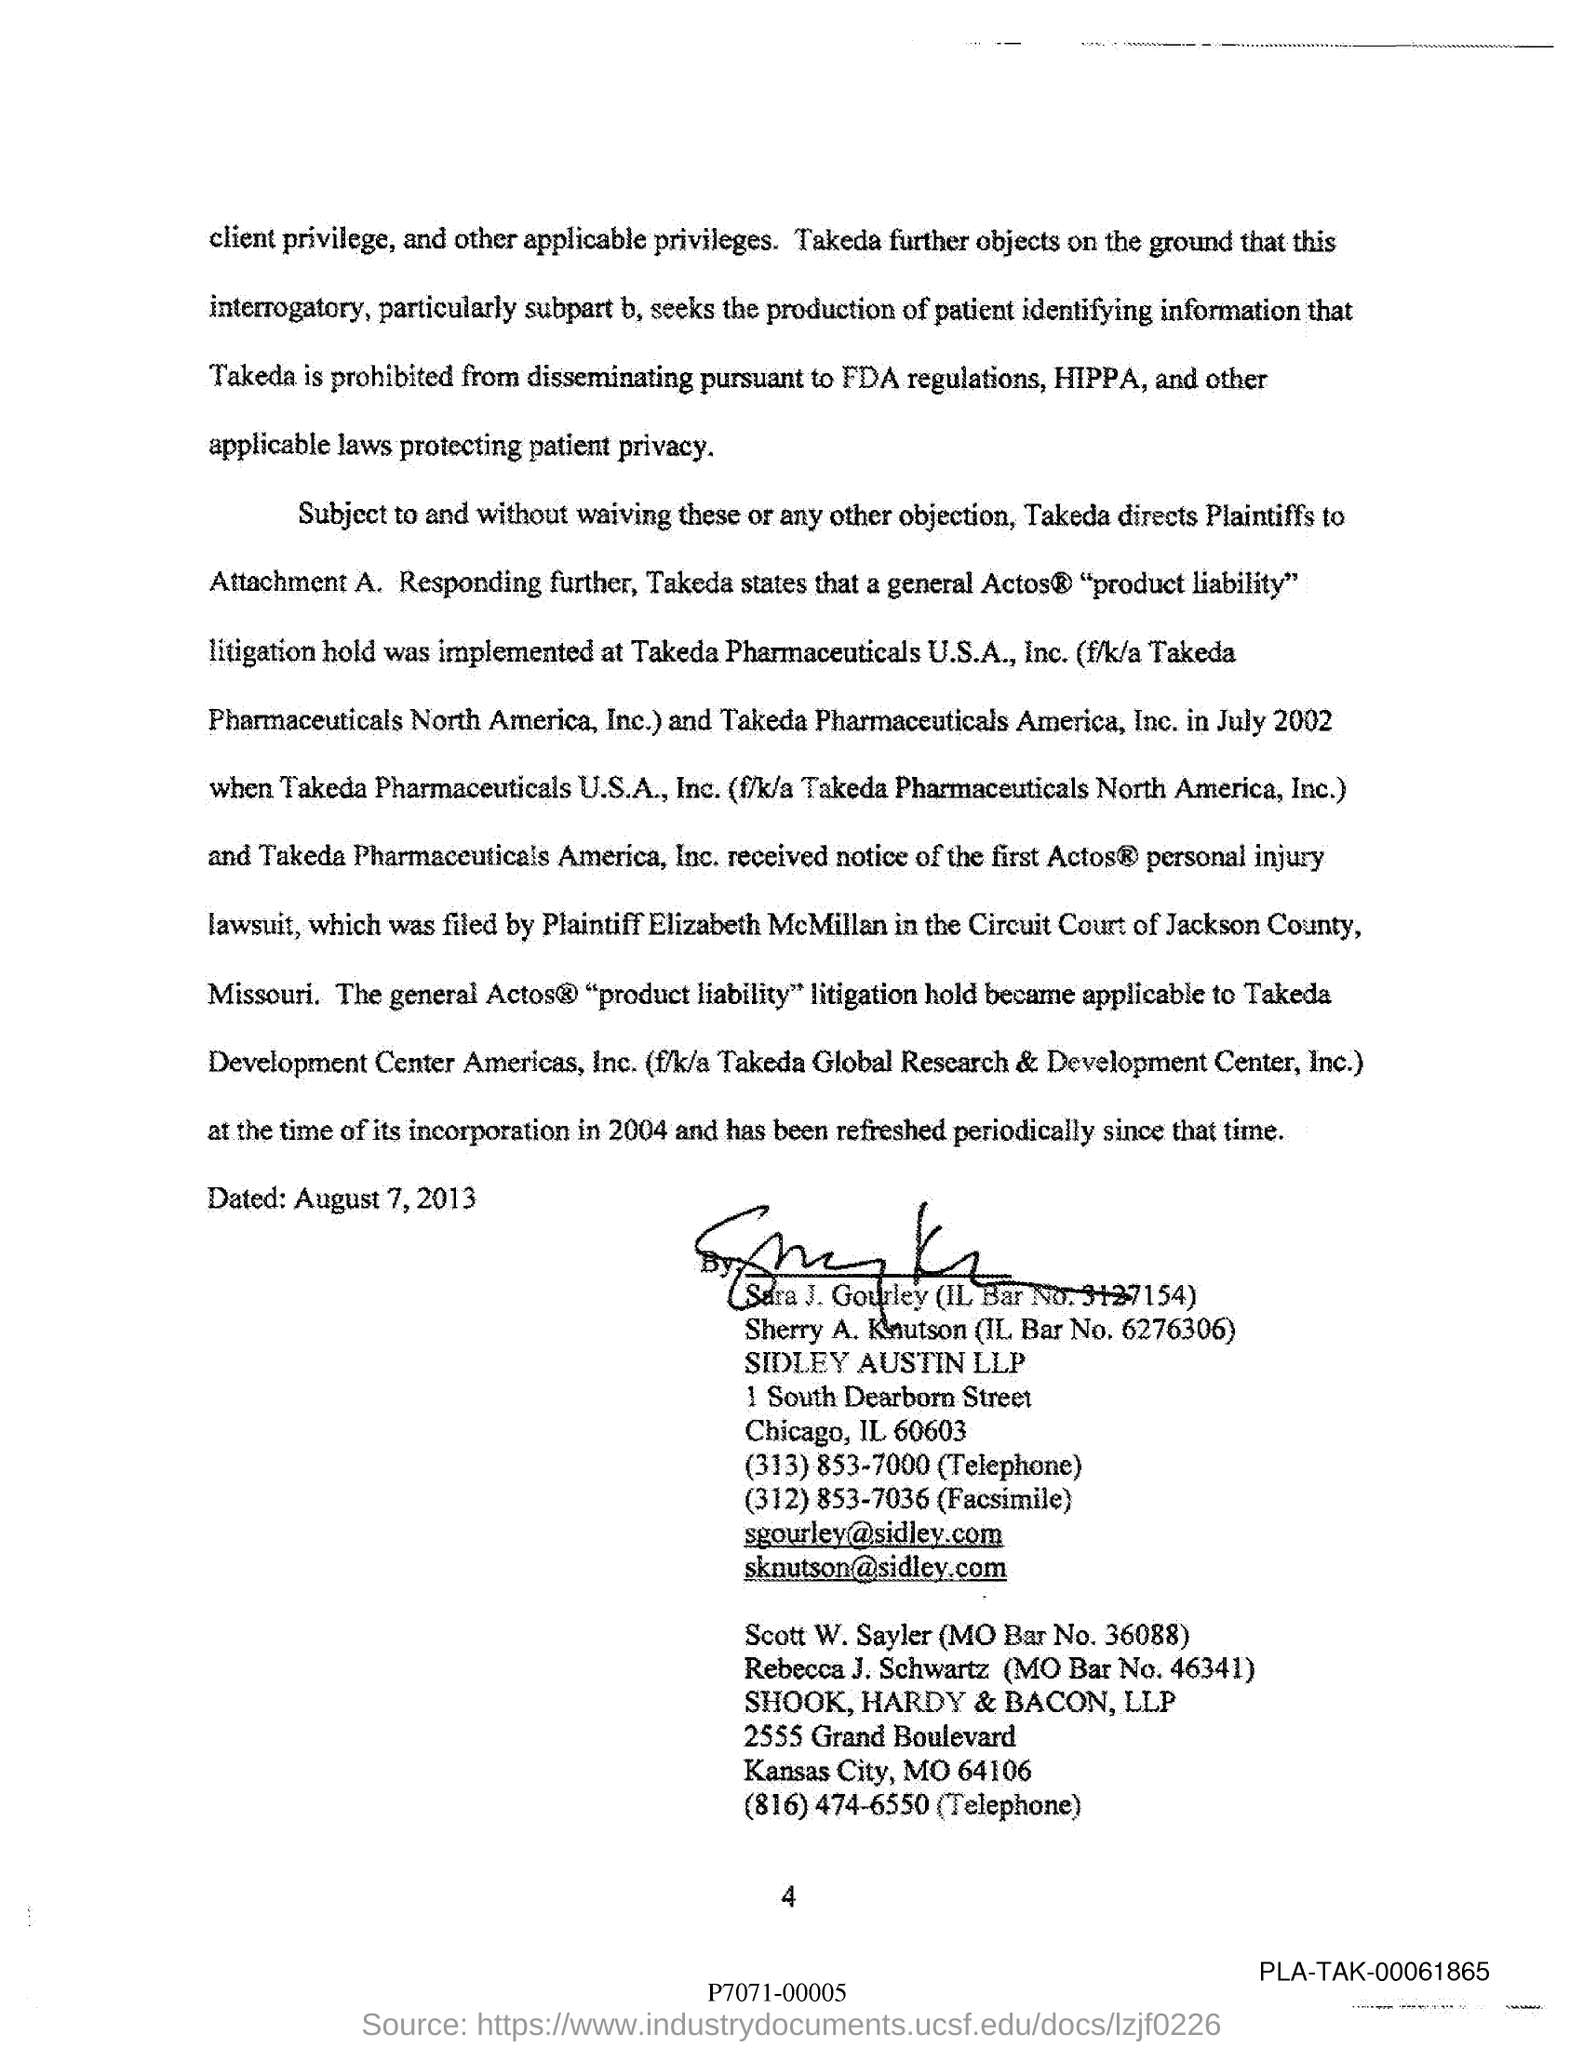Can you tell us more about the case mentioned in the document? The document appears to be related to a 'product liability' litigation involving Takeda Pharmaceuticals U.S.A., Inc. It mentions an Actos® product liability hold being implemented in July 2002. It's part of a legal notice related to the ongoing litigation proceedings. 